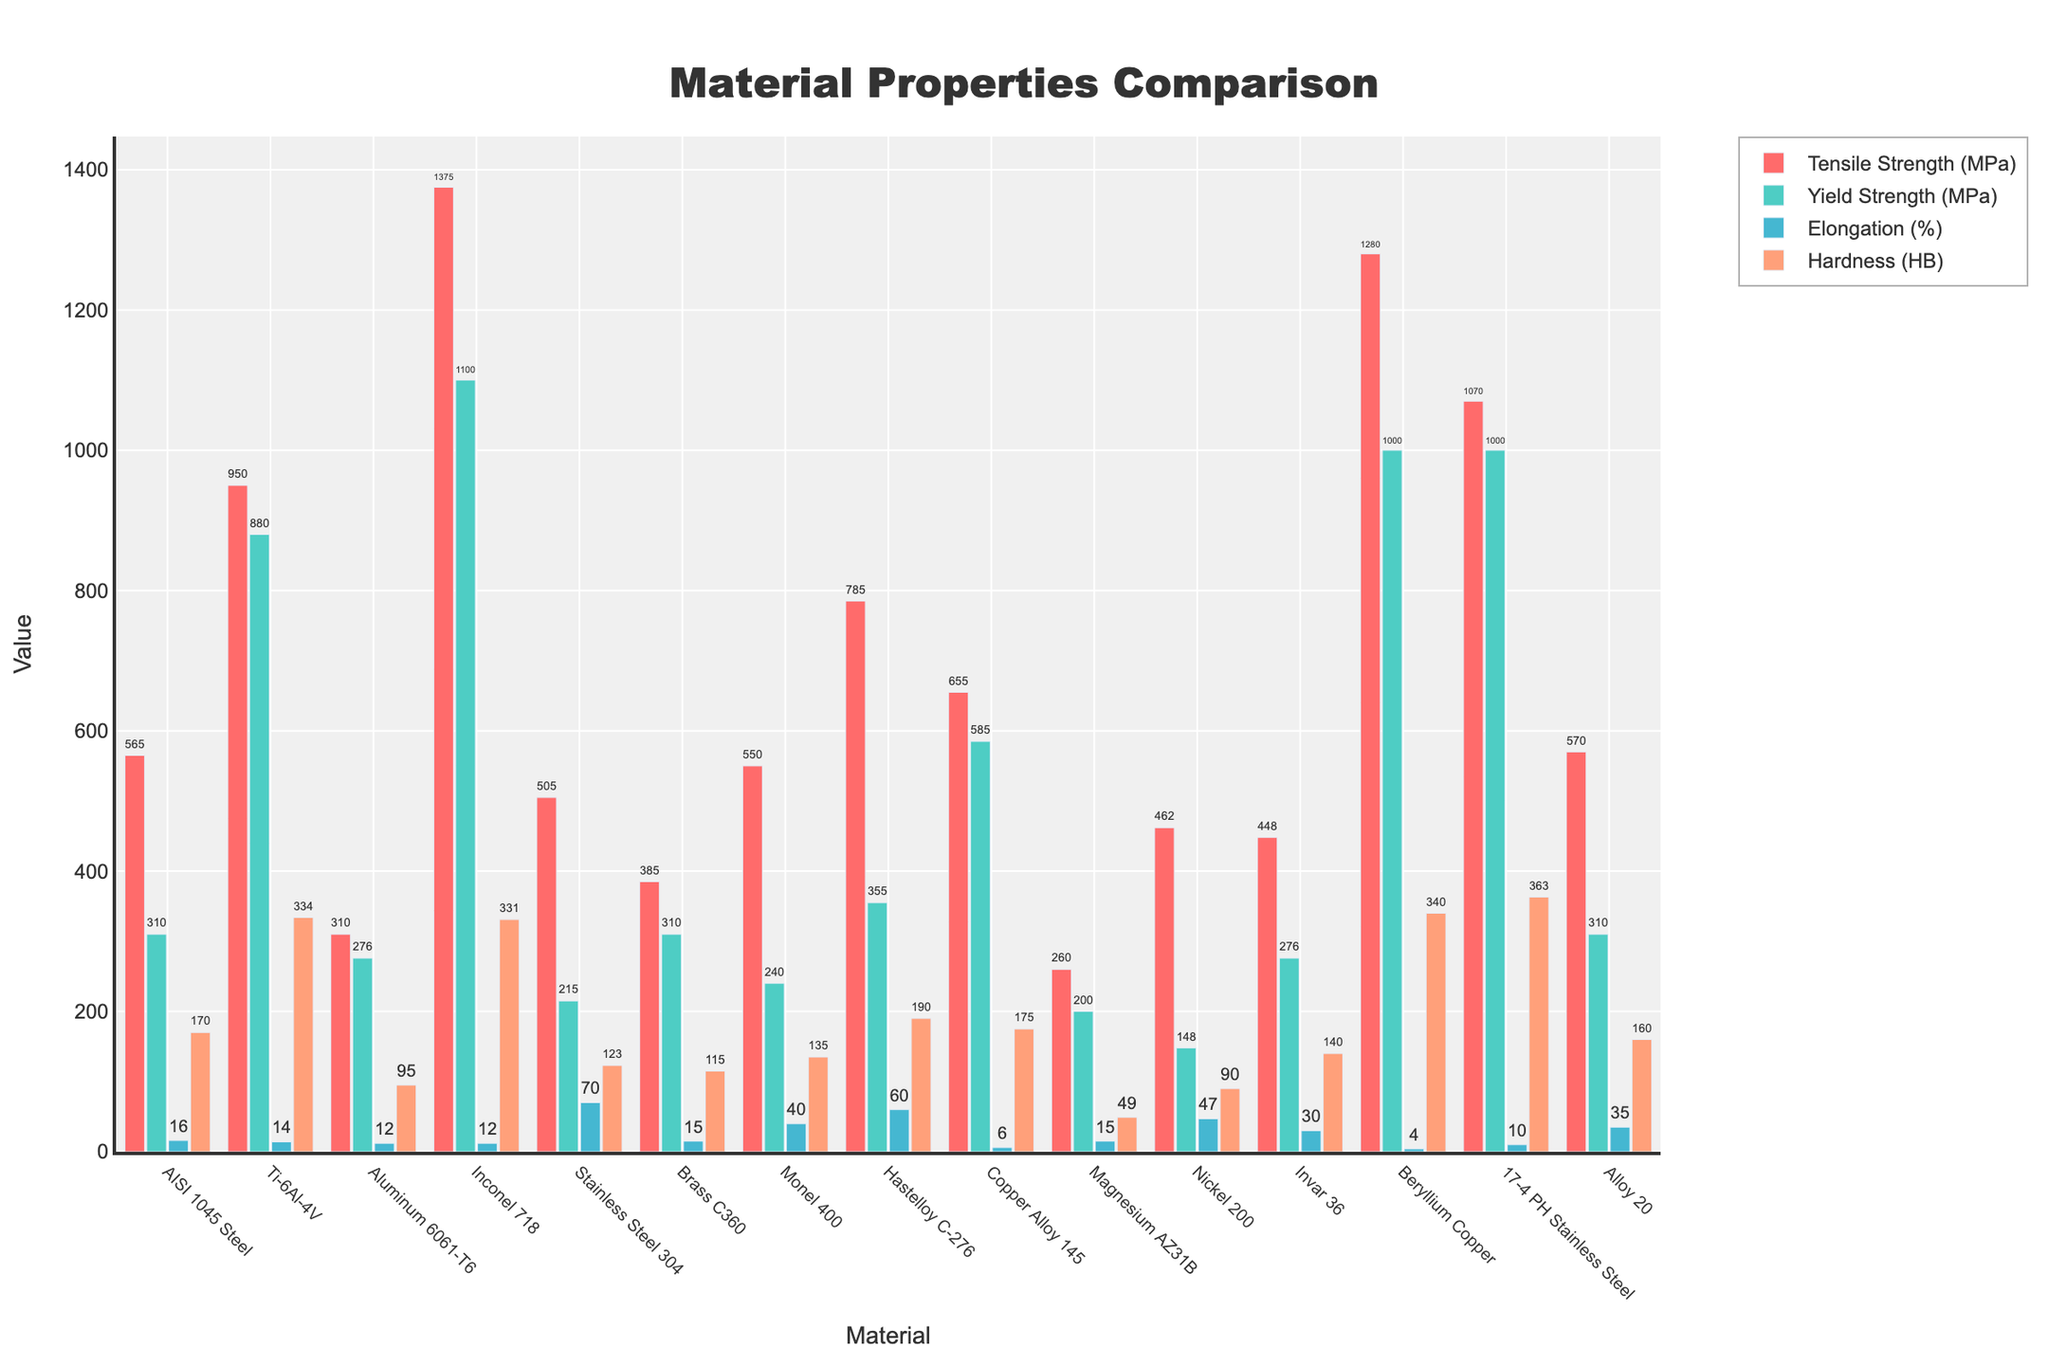Which material has the highest tensile strength? By visually comparing the heights of the bars representing tensile strength for each material, we can see that Inconel 718 has the highest bar.
Answer: Inconel 718 What is the difference between the hardiness (HB) of Titanium alloy (Ti-6Al-4V) and Aluminum 6061-T6? The hardness of Ti-6Al-4V is 334, and for Aluminum 6061-T6, it is 95. Subtracting 95 from 334 gives the difference.
Answer: 239 Which material has a yield strength greater than 900 MPa but less than 1000 MPa? By examining the bars representing yield strength, we see only Beryllium Copper, Ti-6Al-4V, and 17-4 PH Stainless Steel fall into this range.
Answer: Ti-6Al-4V and 17-4 PH Stainless Steel Which material shows the largest elongation percentage? By evaluating the bars indicating elongation percentage, Stainless Steel 304 has the highest bar at 70%.
Answer: Stainless Steel 304 How does the tensile strength of AISI 1045 Steel compare to Alloy 20 and Monel 400? AISI 1045 Steel has a tensile strength of 565 MPa, Alloy 20 has 570 MPa, and Monel 400 has 550 MPa. We compare the numerical values directly.
Answer: Alloy 20 > AISI 1045 Steel > Monel 400 What is the sum of the yield strengths of Hastelloy C-276 and Invar 36? Hastelloy C-276 has a yield strength of 355 MPa, and Invar 36 has a yield strength of 276 MPa. Adding these values results in 355 + 276.
Answer: 631 Which materials have a hardness (HB) between 100 and 150? By examining the bars representing hardness, the relevant materials are Brass C360, Nickel 200, and Monel 400.
Answer: Brass C360, Nickel 200, Monel 400 Does Magnesium AZ31B have a higher elongation percentage than Nickel 200? Magnesium AZ31B has an elongation percentage of 15%, while Nickel 200 has 47%. Since 15% is less than 47%, no.
Answer: No If we rank the materials by elongation (%), where does Copper Alloy 145 stand? By visually determining the elongation bars, Copper Alloy 145, with 6%, stands above Beryllium Copper (4%) and below Aluminum 6061-T6 (12%).
Answer: Second to last 